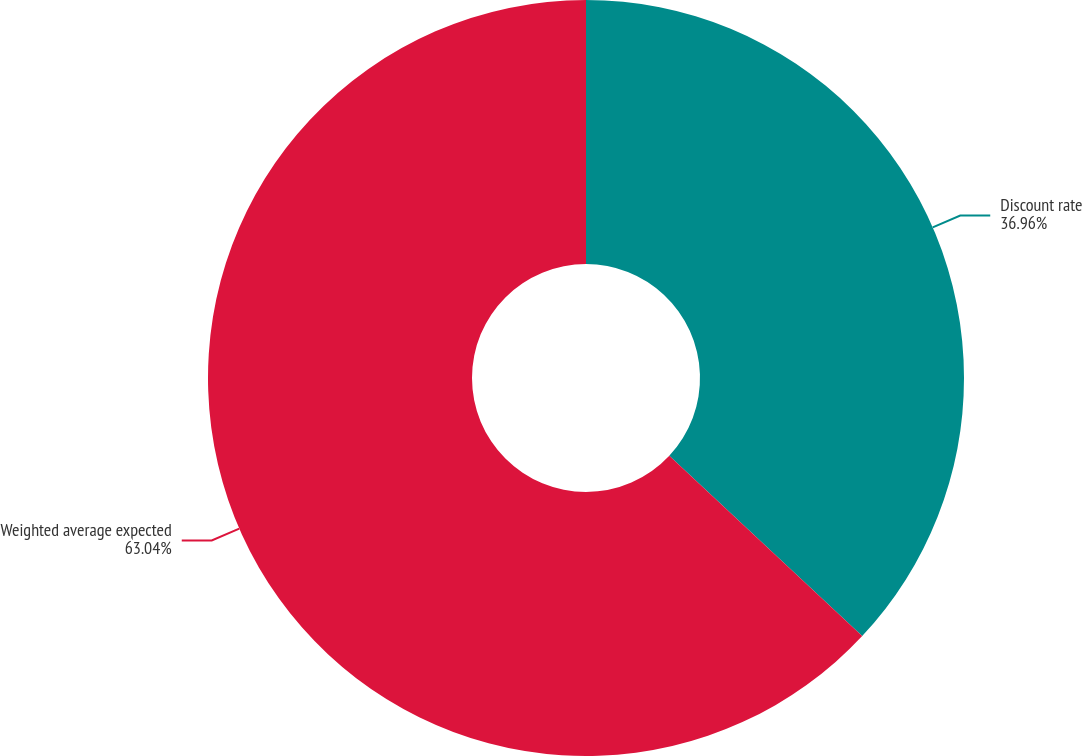Convert chart. <chart><loc_0><loc_0><loc_500><loc_500><pie_chart><fcel>Discount rate<fcel>Weighted average expected<nl><fcel>36.96%<fcel>63.04%<nl></chart> 